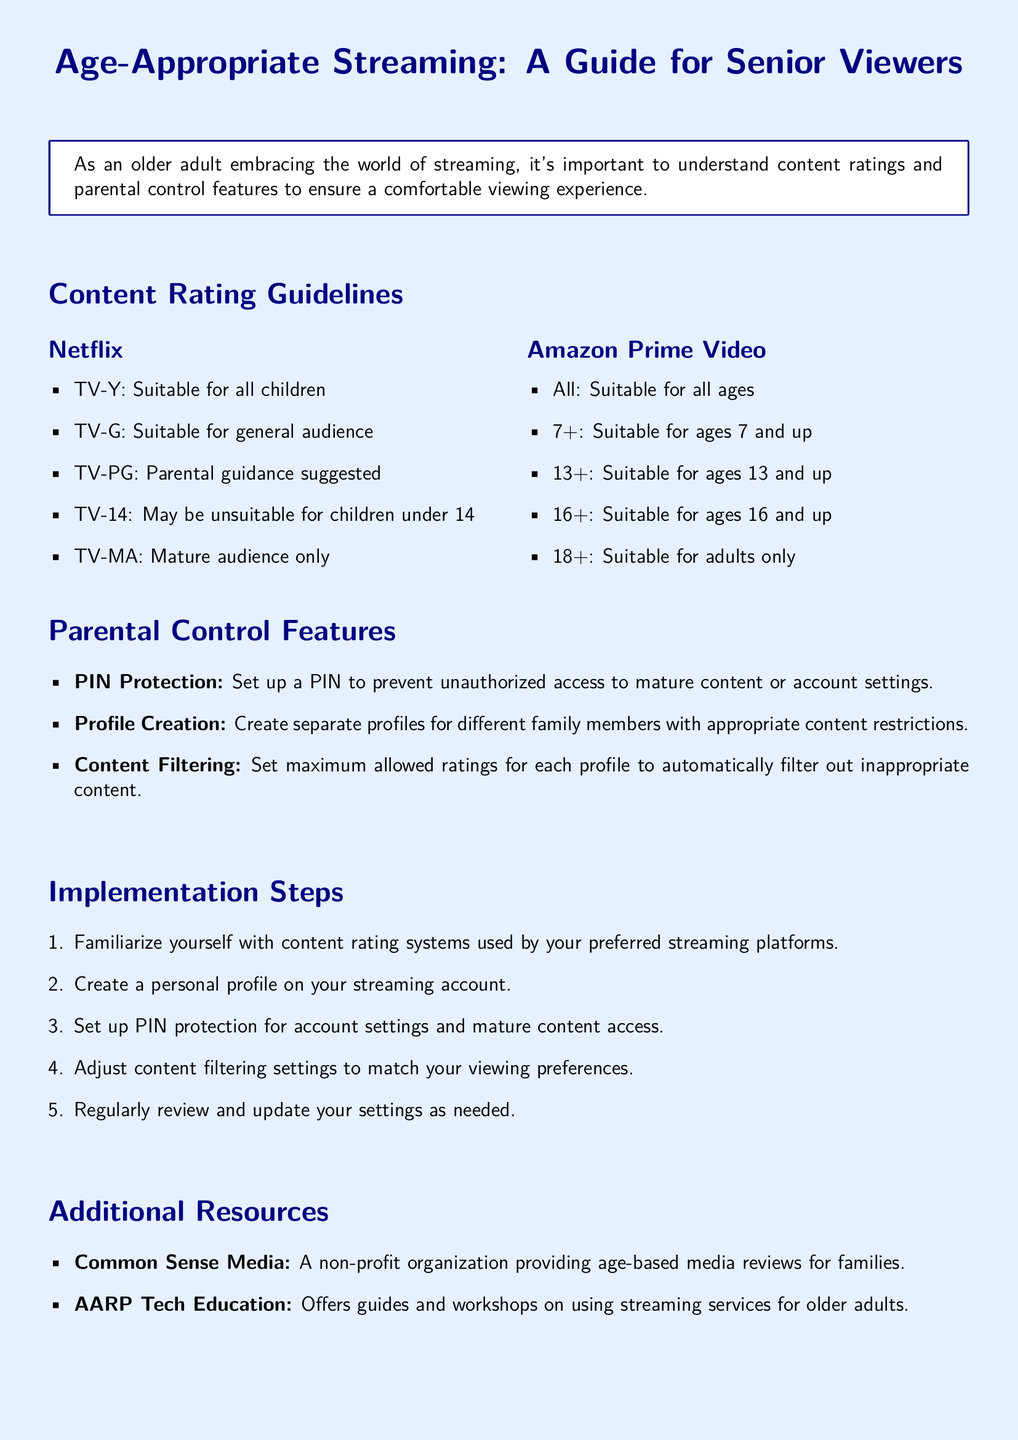What is the purpose of the document? The document serves as a guide for older adults regarding content ratings and parental control features on streaming platforms.
Answer: A guide for senior viewers What does TV-G stand for in Netflix ratings? TV-G stands for "Suitable for general audience" under Netflix's content rating system.
Answer: Suitable for general audience Which streaming platform mentions 7+ as a content rating? Amazon Prime Video specifies 7+ as a content rating suitable for ages 7 and up.
Answer: Amazon Prime Video What is one method to restrict access to mature content? PIN Protection is a method to restrict access by requiring a PIN to access mature content.
Answer: PIN Protection How many steps are listed for setting up parental controls? There are five steps outlined for setting up parental controls in the document.
Answer: Five steps Which organization provides age-based media reviews? Common Sense Media is mentioned as a non-profit providing age-based media reviews.
Answer: Common Sense Media What type of filtering can be set according to the document? Content Filtering allows users to set maximum allowed ratings for profiles.
Answer: Content Filtering What does the 18+ rating indicate on Amazon Prime Video? The 18+ rating indicates that the content is suitable for adults only.
Answer: Adults only 